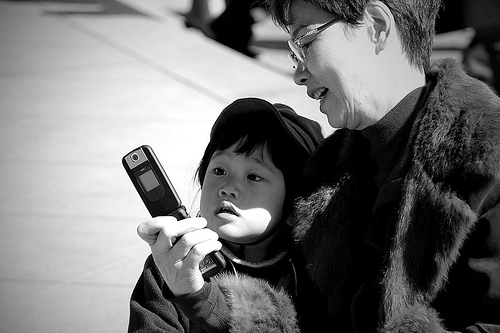What could the adult be teaching the child using the phone? The adult might be teaching the child how to use a feature on the phone, sharing a special moment through a photo or video, or they could simply be enjoying a game or an interactive app together. 